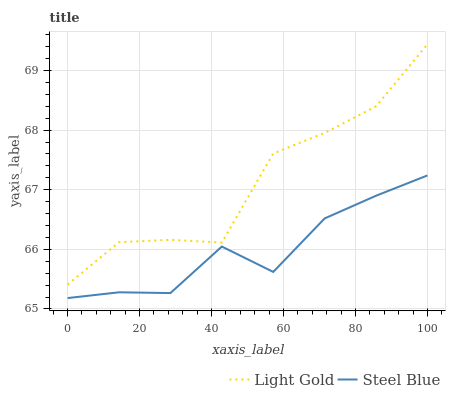Does Steel Blue have the minimum area under the curve?
Answer yes or no. Yes. Does Light Gold have the maximum area under the curve?
Answer yes or no. Yes. Does Steel Blue have the maximum area under the curve?
Answer yes or no. No. Is Steel Blue the smoothest?
Answer yes or no. Yes. Is Light Gold the roughest?
Answer yes or no. Yes. Is Steel Blue the roughest?
Answer yes or no. No. Does Steel Blue have the lowest value?
Answer yes or no. Yes. Does Light Gold have the highest value?
Answer yes or no. Yes. Does Steel Blue have the highest value?
Answer yes or no. No. Is Steel Blue less than Light Gold?
Answer yes or no. Yes. Is Light Gold greater than Steel Blue?
Answer yes or no. Yes. Does Steel Blue intersect Light Gold?
Answer yes or no. No. 